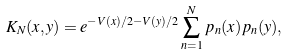<formula> <loc_0><loc_0><loc_500><loc_500>K _ { N } ( x , y ) = e ^ { - V ( x ) / 2 - V ( y ) / 2 } \sum _ { n = 1 } ^ { N } p _ { n } ( x ) p _ { n } ( y ) ,</formula> 